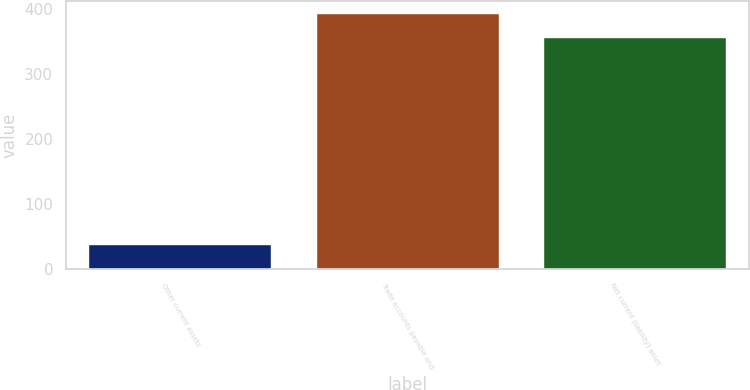Convert chart to OTSL. <chart><loc_0><loc_0><loc_500><loc_500><bar_chart><fcel>Other current assets<fcel>Trade accounts payable and<fcel>Net current (liability) asset<nl><fcel>37<fcel>393<fcel>356<nl></chart> 